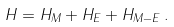<formula> <loc_0><loc_0><loc_500><loc_500>H = H _ { M } + H _ { E } + H _ { M - E } \, .</formula> 